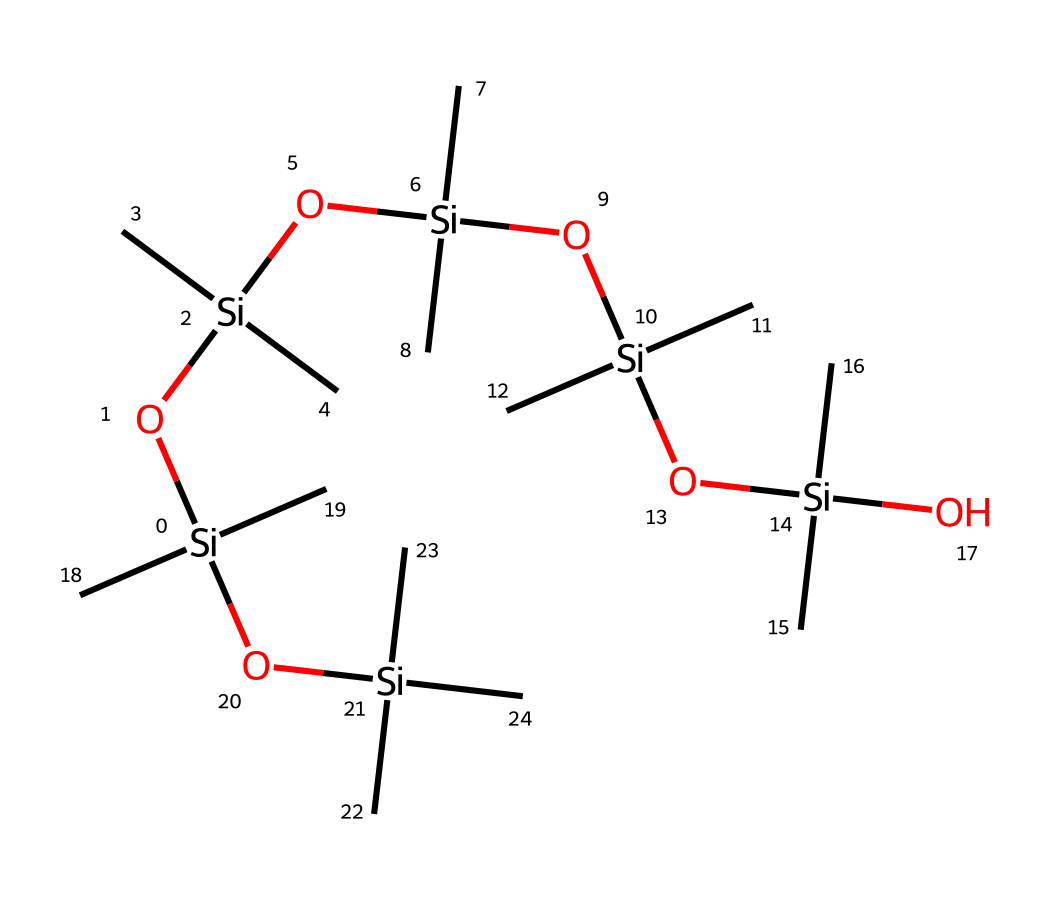how many silicon atoms are present in the structure? By examining the SMILES representation, we can identify the number of silicon (Si) atoms. In this structure, each occurrence of 'Si' indicates a silicon atom. Counting all the 'Si' entries in the SMILES, we find there are five silicon atoms.
Answer: five what functional groups are present in this structure? The SMILES representation shows multiple functional groups including silanol (Si-OH) and ether (Si-O-Si) linkages. The repeating units indicate the presence of siloxane bonds (Si-O) along with terminal silanol groups on the silicon atoms. This combination characterizes the typical functionality seen in siloxanes.
Answer: silanol and siloxane what is the primary purpose of this chemical in food-grade silicone utensils? The primary purpose of this siloxane-based chemical is to provide flexibility and heat resistance, essential for food-grade silicone utensils. The structure allows for flexibility and thermal stability, important for kitchen applications like stirring ramen.
Answer: flexibility and heat resistance what does the repeated 'C' in this chemical structure indicate? The repeated 'C' indicates the presence of methyl (CH3) groups attached to the silicon atoms. Methyl groups contribute to the hydrophobic characteristics of the silicone, enhancing its non-stick properties, which are beneficial in food applications.
Answer: methyl groups what type of chemical bonds connect the silicon and oxygen atoms? The bonds connecting silicon and oxygen atoms in siloxanes are covalent bonds. These bonds occur because silicon can form strong bonds with oxygen, contributing to the stability and strength of the siloxane network in the structure.
Answer: covalent bonds how many oxygen atoms are present in the structure? Counting the 'O' entries in the SMILES representation allows us to determine the number of oxygen atoms. There are six occurrences of 'O', indicating the presence of six oxygen atoms in this siloxane structure.
Answer: six 